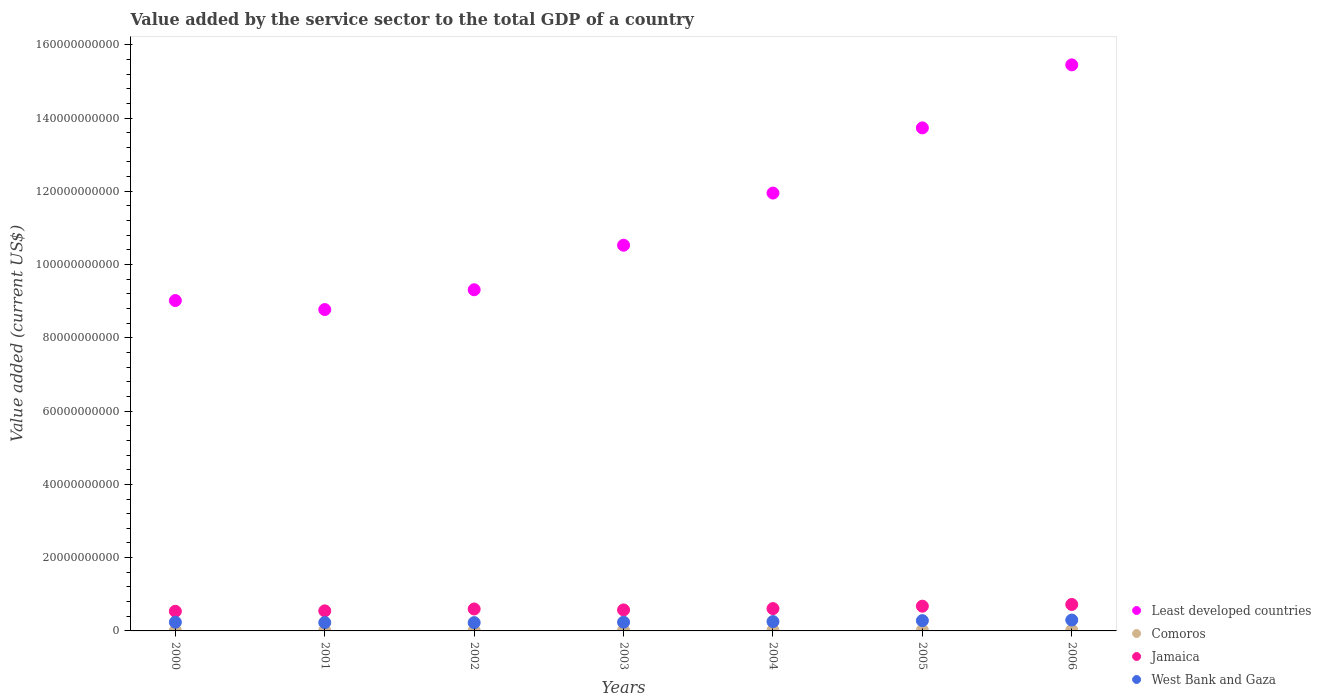Is the number of dotlines equal to the number of legend labels?
Keep it short and to the point. Yes. What is the value added by the service sector to the total GDP in Least developed countries in 2003?
Your answer should be very brief. 1.05e+11. Across all years, what is the maximum value added by the service sector to the total GDP in Jamaica?
Your response must be concise. 7.22e+09. Across all years, what is the minimum value added by the service sector to the total GDP in Jamaica?
Keep it short and to the point. 5.36e+09. In which year was the value added by the service sector to the total GDP in Comoros maximum?
Offer a very short reply. 2006. What is the total value added by the service sector to the total GDP in Comoros in the graph?
Your answer should be very brief. 1.02e+09. What is the difference between the value added by the service sector to the total GDP in Jamaica in 2000 and that in 2003?
Your answer should be very brief. -3.69e+08. What is the difference between the value added by the service sector to the total GDP in Comoros in 2003 and the value added by the service sector to the total GDP in Jamaica in 2005?
Offer a terse response. -6.60e+09. What is the average value added by the service sector to the total GDP in West Bank and Gaza per year?
Provide a short and direct response. 2.52e+09. In the year 2000, what is the difference between the value added by the service sector to the total GDP in West Bank and Gaza and value added by the service sector to the total GDP in Jamaica?
Give a very brief answer. -2.99e+09. What is the ratio of the value added by the service sector to the total GDP in Jamaica in 2001 to that in 2002?
Your answer should be compact. 0.91. Is the value added by the service sector to the total GDP in West Bank and Gaza in 2002 less than that in 2003?
Give a very brief answer. Yes. Is the difference between the value added by the service sector to the total GDP in West Bank and Gaza in 2001 and 2004 greater than the difference between the value added by the service sector to the total GDP in Jamaica in 2001 and 2004?
Keep it short and to the point. Yes. What is the difference between the highest and the second highest value added by the service sector to the total GDP in West Bank and Gaza?
Provide a short and direct response. 1.62e+08. What is the difference between the highest and the lowest value added by the service sector to the total GDP in West Bank and Gaza?
Offer a terse response. 7.10e+08. In how many years, is the value added by the service sector to the total GDP in Jamaica greater than the average value added by the service sector to the total GDP in Jamaica taken over all years?
Give a very brief answer. 3. Is the sum of the value added by the service sector to the total GDP in Jamaica in 2000 and 2003 greater than the maximum value added by the service sector to the total GDP in West Bank and Gaza across all years?
Provide a short and direct response. Yes. Is it the case that in every year, the sum of the value added by the service sector to the total GDP in Jamaica and value added by the service sector to the total GDP in West Bank and Gaza  is greater than the sum of value added by the service sector to the total GDP in Least developed countries and value added by the service sector to the total GDP in Comoros?
Give a very brief answer. No. Does the value added by the service sector to the total GDP in Jamaica monotonically increase over the years?
Give a very brief answer. No. Is the value added by the service sector to the total GDP in Comoros strictly greater than the value added by the service sector to the total GDP in West Bank and Gaza over the years?
Make the answer very short. No. How many years are there in the graph?
Provide a short and direct response. 7. Does the graph contain grids?
Keep it short and to the point. No. How many legend labels are there?
Ensure brevity in your answer.  4. What is the title of the graph?
Provide a short and direct response. Value added by the service sector to the total GDP of a country. What is the label or title of the X-axis?
Give a very brief answer. Years. What is the label or title of the Y-axis?
Give a very brief answer. Value added (current US$). What is the Value added (current US$) in Least developed countries in 2000?
Ensure brevity in your answer.  9.02e+1. What is the Value added (current US$) in Comoros in 2000?
Offer a very short reply. 1.02e+08. What is the Value added (current US$) in Jamaica in 2000?
Give a very brief answer. 5.36e+09. What is the Value added (current US$) of West Bank and Gaza in 2000?
Offer a very short reply. 2.37e+09. What is the Value added (current US$) in Least developed countries in 2001?
Give a very brief answer. 8.77e+1. What is the Value added (current US$) of Comoros in 2001?
Your answer should be compact. 1.04e+08. What is the Value added (current US$) of Jamaica in 2001?
Give a very brief answer. 5.47e+09. What is the Value added (current US$) in West Bank and Gaza in 2001?
Make the answer very short. 2.28e+09. What is the Value added (current US$) in Least developed countries in 2002?
Offer a very short reply. 9.31e+1. What is the Value added (current US$) in Comoros in 2002?
Offer a terse response. 1.16e+08. What is the Value added (current US$) in Jamaica in 2002?
Your answer should be very brief. 5.99e+09. What is the Value added (current US$) of West Bank and Gaza in 2002?
Offer a very short reply. 2.26e+09. What is the Value added (current US$) of Least developed countries in 2003?
Your answer should be very brief. 1.05e+11. What is the Value added (current US$) in Comoros in 2003?
Provide a succinct answer. 1.50e+08. What is the Value added (current US$) in Jamaica in 2003?
Make the answer very short. 5.73e+09. What is the Value added (current US$) of West Bank and Gaza in 2003?
Your answer should be very brief. 2.38e+09. What is the Value added (current US$) in Least developed countries in 2004?
Make the answer very short. 1.20e+11. What is the Value added (current US$) in Comoros in 2004?
Make the answer very short. 1.73e+08. What is the Value added (current US$) of Jamaica in 2004?
Make the answer very short. 6.09e+09. What is the Value added (current US$) in West Bank and Gaza in 2004?
Provide a succinct answer. 2.55e+09. What is the Value added (current US$) of Least developed countries in 2005?
Your answer should be very brief. 1.37e+11. What is the Value added (current US$) of Comoros in 2005?
Your response must be concise. 1.79e+08. What is the Value added (current US$) in Jamaica in 2005?
Your answer should be compact. 6.75e+09. What is the Value added (current US$) in West Bank and Gaza in 2005?
Give a very brief answer. 2.81e+09. What is the Value added (current US$) of Least developed countries in 2006?
Keep it short and to the point. 1.55e+11. What is the Value added (current US$) of Comoros in 2006?
Give a very brief answer. 1.92e+08. What is the Value added (current US$) in Jamaica in 2006?
Your response must be concise. 7.22e+09. What is the Value added (current US$) in West Bank and Gaza in 2006?
Make the answer very short. 2.97e+09. Across all years, what is the maximum Value added (current US$) of Least developed countries?
Give a very brief answer. 1.55e+11. Across all years, what is the maximum Value added (current US$) in Comoros?
Keep it short and to the point. 1.92e+08. Across all years, what is the maximum Value added (current US$) in Jamaica?
Offer a very short reply. 7.22e+09. Across all years, what is the maximum Value added (current US$) of West Bank and Gaza?
Your answer should be very brief. 2.97e+09. Across all years, what is the minimum Value added (current US$) in Least developed countries?
Keep it short and to the point. 8.77e+1. Across all years, what is the minimum Value added (current US$) in Comoros?
Make the answer very short. 1.02e+08. Across all years, what is the minimum Value added (current US$) of Jamaica?
Provide a short and direct response. 5.36e+09. Across all years, what is the minimum Value added (current US$) in West Bank and Gaza?
Make the answer very short. 2.26e+09. What is the total Value added (current US$) of Least developed countries in the graph?
Offer a very short reply. 7.88e+11. What is the total Value added (current US$) of Comoros in the graph?
Your response must be concise. 1.02e+09. What is the total Value added (current US$) in Jamaica in the graph?
Keep it short and to the point. 4.26e+1. What is the total Value added (current US$) in West Bank and Gaza in the graph?
Provide a short and direct response. 1.76e+1. What is the difference between the Value added (current US$) in Least developed countries in 2000 and that in 2001?
Offer a very short reply. 2.46e+09. What is the difference between the Value added (current US$) of Comoros in 2000 and that in 2001?
Give a very brief answer. -2.16e+06. What is the difference between the Value added (current US$) in Jamaica in 2000 and that in 2001?
Your response must be concise. -1.09e+08. What is the difference between the Value added (current US$) of West Bank and Gaza in 2000 and that in 2001?
Your answer should be compact. 9.27e+07. What is the difference between the Value added (current US$) in Least developed countries in 2000 and that in 2002?
Ensure brevity in your answer.  -2.95e+09. What is the difference between the Value added (current US$) of Comoros in 2000 and that in 2002?
Provide a succinct answer. -1.46e+07. What is the difference between the Value added (current US$) of Jamaica in 2000 and that in 2002?
Your answer should be very brief. -6.23e+08. What is the difference between the Value added (current US$) in West Bank and Gaza in 2000 and that in 2002?
Your answer should be very brief. 1.14e+08. What is the difference between the Value added (current US$) in Least developed countries in 2000 and that in 2003?
Ensure brevity in your answer.  -1.51e+1. What is the difference between the Value added (current US$) of Comoros in 2000 and that in 2003?
Provide a short and direct response. -4.79e+07. What is the difference between the Value added (current US$) of Jamaica in 2000 and that in 2003?
Make the answer very short. -3.69e+08. What is the difference between the Value added (current US$) of West Bank and Gaza in 2000 and that in 2003?
Provide a short and direct response. -2.80e+06. What is the difference between the Value added (current US$) of Least developed countries in 2000 and that in 2004?
Provide a succinct answer. -2.93e+1. What is the difference between the Value added (current US$) in Comoros in 2000 and that in 2004?
Keep it short and to the point. -7.17e+07. What is the difference between the Value added (current US$) of Jamaica in 2000 and that in 2004?
Give a very brief answer. -7.27e+08. What is the difference between the Value added (current US$) of West Bank and Gaza in 2000 and that in 2004?
Make the answer very short. -1.76e+08. What is the difference between the Value added (current US$) of Least developed countries in 2000 and that in 2005?
Provide a succinct answer. -4.71e+1. What is the difference between the Value added (current US$) of Comoros in 2000 and that in 2005?
Your response must be concise. -7.70e+07. What is the difference between the Value added (current US$) in Jamaica in 2000 and that in 2005?
Your response must be concise. -1.39e+09. What is the difference between the Value added (current US$) of West Bank and Gaza in 2000 and that in 2005?
Ensure brevity in your answer.  -4.35e+08. What is the difference between the Value added (current US$) in Least developed countries in 2000 and that in 2006?
Keep it short and to the point. -6.43e+1. What is the difference between the Value added (current US$) in Comoros in 2000 and that in 2006?
Provide a short and direct response. -9.08e+07. What is the difference between the Value added (current US$) in Jamaica in 2000 and that in 2006?
Ensure brevity in your answer.  -1.86e+09. What is the difference between the Value added (current US$) in West Bank and Gaza in 2000 and that in 2006?
Give a very brief answer. -5.97e+08. What is the difference between the Value added (current US$) in Least developed countries in 2001 and that in 2002?
Your answer should be compact. -5.40e+09. What is the difference between the Value added (current US$) in Comoros in 2001 and that in 2002?
Your answer should be very brief. -1.24e+07. What is the difference between the Value added (current US$) of Jamaica in 2001 and that in 2002?
Offer a very short reply. -5.14e+08. What is the difference between the Value added (current US$) in West Bank and Gaza in 2001 and that in 2002?
Offer a very short reply. 2.08e+07. What is the difference between the Value added (current US$) of Least developed countries in 2001 and that in 2003?
Provide a short and direct response. -1.76e+1. What is the difference between the Value added (current US$) in Comoros in 2001 and that in 2003?
Your answer should be compact. -4.57e+07. What is the difference between the Value added (current US$) of Jamaica in 2001 and that in 2003?
Your answer should be compact. -2.60e+08. What is the difference between the Value added (current US$) of West Bank and Gaza in 2001 and that in 2003?
Ensure brevity in your answer.  -9.55e+07. What is the difference between the Value added (current US$) of Least developed countries in 2001 and that in 2004?
Provide a short and direct response. -3.18e+1. What is the difference between the Value added (current US$) in Comoros in 2001 and that in 2004?
Keep it short and to the point. -6.96e+07. What is the difference between the Value added (current US$) of Jamaica in 2001 and that in 2004?
Keep it short and to the point. -6.18e+08. What is the difference between the Value added (current US$) in West Bank and Gaza in 2001 and that in 2004?
Ensure brevity in your answer.  -2.69e+08. What is the difference between the Value added (current US$) in Least developed countries in 2001 and that in 2005?
Provide a succinct answer. -4.96e+1. What is the difference between the Value added (current US$) of Comoros in 2001 and that in 2005?
Your answer should be compact. -7.48e+07. What is the difference between the Value added (current US$) in Jamaica in 2001 and that in 2005?
Make the answer very short. -1.28e+09. What is the difference between the Value added (current US$) in West Bank and Gaza in 2001 and that in 2005?
Give a very brief answer. -5.28e+08. What is the difference between the Value added (current US$) of Least developed countries in 2001 and that in 2006?
Your answer should be very brief. -6.68e+1. What is the difference between the Value added (current US$) of Comoros in 2001 and that in 2006?
Your response must be concise. -8.86e+07. What is the difference between the Value added (current US$) in Jamaica in 2001 and that in 2006?
Make the answer very short. -1.75e+09. What is the difference between the Value added (current US$) in West Bank and Gaza in 2001 and that in 2006?
Make the answer very short. -6.89e+08. What is the difference between the Value added (current US$) in Least developed countries in 2002 and that in 2003?
Give a very brief answer. -1.22e+1. What is the difference between the Value added (current US$) in Comoros in 2002 and that in 2003?
Provide a succinct answer. -3.34e+07. What is the difference between the Value added (current US$) of Jamaica in 2002 and that in 2003?
Provide a short and direct response. 2.54e+08. What is the difference between the Value added (current US$) in West Bank and Gaza in 2002 and that in 2003?
Make the answer very short. -1.16e+08. What is the difference between the Value added (current US$) in Least developed countries in 2002 and that in 2004?
Your response must be concise. -2.64e+1. What is the difference between the Value added (current US$) of Comoros in 2002 and that in 2004?
Offer a very short reply. -5.72e+07. What is the difference between the Value added (current US$) in Jamaica in 2002 and that in 2004?
Offer a terse response. -1.04e+08. What is the difference between the Value added (current US$) of West Bank and Gaza in 2002 and that in 2004?
Offer a terse response. -2.89e+08. What is the difference between the Value added (current US$) of Least developed countries in 2002 and that in 2005?
Your answer should be compact. -4.42e+1. What is the difference between the Value added (current US$) of Comoros in 2002 and that in 2005?
Offer a terse response. -6.24e+07. What is the difference between the Value added (current US$) of Jamaica in 2002 and that in 2005?
Make the answer very short. -7.65e+08. What is the difference between the Value added (current US$) of West Bank and Gaza in 2002 and that in 2005?
Your response must be concise. -5.49e+08. What is the difference between the Value added (current US$) of Least developed countries in 2002 and that in 2006?
Your answer should be compact. -6.14e+1. What is the difference between the Value added (current US$) in Comoros in 2002 and that in 2006?
Ensure brevity in your answer.  -7.62e+07. What is the difference between the Value added (current US$) of Jamaica in 2002 and that in 2006?
Keep it short and to the point. -1.23e+09. What is the difference between the Value added (current US$) of West Bank and Gaza in 2002 and that in 2006?
Provide a succinct answer. -7.10e+08. What is the difference between the Value added (current US$) of Least developed countries in 2003 and that in 2004?
Offer a very short reply. -1.42e+1. What is the difference between the Value added (current US$) in Comoros in 2003 and that in 2004?
Give a very brief answer. -2.38e+07. What is the difference between the Value added (current US$) in Jamaica in 2003 and that in 2004?
Offer a terse response. -3.58e+08. What is the difference between the Value added (current US$) in West Bank and Gaza in 2003 and that in 2004?
Keep it short and to the point. -1.73e+08. What is the difference between the Value added (current US$) of Least developed countries in 2003 and that in 2005?
Your answer should be compact. -3.20e+1. What is the difference between the Value added (current US$) of Comoros in 2003 and that in 2005?
Your answer should be very brief. -2.91e+07. What is the difference between the Value added (current US$) of Jamaica in 2003 and that in 2005?
Ensure brevity in your answer.  -1.02e+09. What is the difference between the Value added (current US$) of West Bank and Gaza in 2003 and that in 2005?
Make the answer very short. -4.32e+08. What is the difference between the Value added (current US$) of Least developed countries in 2003 and that in 2006?
Your answer should be compact. -4.92e+1. What is the difference between the Value added (current US$) of Comoros in 2003 and that in 2006?
Provide a short and direct response. -4.28e+07. What is the difference between the Value added (current US$) in Jamaica in 2003 and that in 2006?
Your answer should be very brief. -1.49e+09. What is the difference between the Value added (current US$) in West Bank and Gaza in 2003 and that in 2006?
Your response must be concise. -5.94e+08. What is the difference between the Value added (current US$) of Least developed countries in 2004 and that in 2005?
Your answer should be compact. -1.78e+1. What is the difference between the Value added (current US$) of Comoros in 2004 and that in 2005?
Offer a very short reply. -5.24e+06. What is the difference between the Value added (current US$) of Jamaica in 2004 and that in 2005?
Your answer should be very brief. -6.61e+08. What is the difference between the Value added (current US$) of West Bank and Gaza in 2004 and that in 2005?
Give a very brief answer. -2.59e+08. What is the difference between the Value added (current US$) of Least developed countries in 2004 and that in 2006?
Keep it short and to the point. -3.50e+1. What is the difference between the Value added (current US$) in Comoros in 2004 and that in 2006?
Provide a short and direct response. -1.90e+07. What is the difference between the Value added (current US$) in Jamaica in 2004 and that in 2006?
Your answer should be very brief. -1.13e+09. What is the difference between the Value added (current US$) in West Bank and Gaza in 2004 and that in 2006?
Provide a succinct answer. -4.21e+08. What is the difference between the Value added (current US$) of Least developed countries in 2005 and that in 2006?
Your answer should be very brief. -1.72e+1. What is the difference between the Value added (current US$) in Comoros in 2005 and that in 2006?
Make the answer very short. -1.38e+07. What is the difference between the Value added (current US$) in Jamaica in 2005 and that in 2006?
Offer a terse response. -4.69e+08. What is the difference between the Value added (current US$) of West Bank and Gaza in 2005 and that in 2006?
Give a very brief answer. -1.62e+08. What is the difference between the Value added (current US$) in Least developed countries in 2000 and the Value added (current US$) in Comoros in 2001?
Offer a terse response. 9.01e+1. What is the difference between the Value added (current US$) in Least developed countries in 2000 and the Value added (current US$) in Jamaica in 2001?
Your answer should be compact. 8.47e+1. What is the difference between the Value added (current US$) in Least developed countries in 2000 and the Value added (current US$) in West Bank and Gaza in 2001?
Your response must be concise. 8.79e+1. What is the difference between the Value added (current US$) in Comoros in 2000 and the Value added (current US$) in Jamaica in 2001?
Your answer should be compact. -5.37e+09. What is the difference between the Value added (current US$) in Comoros in 2000 and the Value added (current US$) in West Bank and Gaza in 2001?
Make the answer very short. -2.18e+09. What is the difference between the Value added (current US$) of Jamaica in 2000 and the Value added (current US$) of West Bank and Gaza in 2001?
Make the answer very short. 3.08e+09. What is the difference between the Value added (current US$) in Least developed countries in 2000 and the Value added (current US$) in Comoros in 2002?
Your answer should be compact. 9.01e+1. What is the difference between the Value added (current US$) in Least developed countries in 2000 and the Value added (current US$) in Jamaica in 2002?
Offer a terse response. 8.42e+1. What is the difference between the Value added (current US$) in Least developed countries in 2000 and the Value added (current US$) in West Bank and Gaza in 2002?
Your response must be concise. 8.79e+1. What is the difference between the Value added (current US$) of Comoros in 2000 and the Value added (current US$) of Jamaica in 2002?
Offer a very short reply. -5.89e+09. What is the difference between the Value added (current US$) of Comoros in 2000 and the Value added (current US$) of West Bank and Gaza in 2002?
Provide a short and direct response. -2.16e+09. What is the difference between the Value added (current US$) in Jamaica in 2000 and the Value added (current US$) in West Bank and Gaza in 2002?
Give a very brief answer. 3.11e+09. What is the difference between the Value added (current US$) of Least developed countries in 2000 and the Value added (current US$) of Comoros in 2003?
Offer a terse response. 9.00e+1. What is the difference between the Value added (current US$) in Least developed countries in 2000 and the Value added (current US$) in Jamaica in 2003?
Your answer should be very brief. 8.44e+1. What is the difference between the Value added (current US$) in Least developed countries in 2000 and the Value added (current US$) in West Bank and Gaza in 2003?
Give a very brief answer. 8.78e+1. What is the difference between the Value added (current US$) in Comoros in 2000 and the Value added (current US$) in Jamaica in 2003?
Make the answer very short. -5.63e+09. What is the difference between the Value added (current US$) in Comoros in 2000 and the Value added (current US$) in West Bank and Gaza in 2003?
Your answer should be compact. -2.27e+09. What is the difference between the Value added (current US$) in Jamaica in 2000 and the Value added (current US$) in West Bank and Gaza in 2003?
Your answer should be very brief. 2.99e+09. What is the difference between the Value added (current US$) of Least developed countries in 2000 and the Value added (current US$) of Comoros in 2004?
Offer a very short reply. 9.00e+1. What is the difference between the Value added (current US$) of Least developed countries in 2000 and the Value added (current US$) of Jamaica in 2004?
Your response must be concise. 8.41e+1. What is the difference between the Value added (current US$) in Least developed countries in 2000 and the Value added (current US$) in West Bank and Gaza in 2004?
Your response must be concise. 8.76e+1. What is the difference between the Value added (current US$) in Comoros in 2000 and the Value added (current US$) in Jamaica in 2004?
Give a very brief answer. -5.99e+09. What is the difference between the Value added (current US$) of Comoros in 2000 and the Value added (current US$) of West Bank and Gaza in 2004?
Your answer should be very brief. -2.45e+09. What is the difference between the Value added (current US$) in Jamaica in 2000 and the Value added (current US$) in West Bank and Gaza in 2004?
Provide a succinct answer. 2.82e+09. What is the difference between the Value added (current US$) in Least developed countries in 2000 and the Value added (current US$) in Comoros in 2005?
Offer a terse response. 9.00e+1. What is the difference between the Value added (current US$) of Least developed countries in 2000 and the Value added (current US$) of Jamaica in 2005?
Make the answer very short. 8.34e+1. What is the difference between the Value added (current US$) of Least developed countries in 2000 and the Value added (current US$) of West Bank and Gaza in 2005?
Ensure brevity in your answer.  8.74e+1. What is the difference between the Value added (current US$) of Comoros in 2000 and the Value added (current US$) of Jamaica in 2005?
Make the answer very short. -6.65e+09. What is the difference between the Value added (current US$) of Comoros in 2000 and the Value added (current US$) of West Bank and Gaza in 2005?
Provide a short and direct response. -2.71e+09. What is the difference between the Value added (current US$) of Jamaica in 2000 and the Value added (current US$) of West Bank and Gaza in 2005?
Your answer should be compact. 2.56e+09. What is the difference between the Value added (current US$) of Least developed countries in 2000 and the Value added (current US$) of Comoros in 2006?
Keep it short and to the point. 9.00e+1. What is the difference between the Value added (current US$) of Least developed countries in 2000 and the Value added (current US$) of Jamaica in 2006?
Offer a terse response. 8.30e+1. What is the difference between the Value added (current US$) of Least developed countries in 2000 and the Value added (current US$) of West Bank and Gaza in 2006?
Provide a succinct answer. 8.72e+1. What is the difference between the Value added (current US$) of Comoros in 2000 and the Value added (current US$) of Jamaica in 2006?
Provide a succinct answer. -7.12e+09. What is the difference between the Value added (current US$) of Comoros in 2000 and the Value added (current US$) of West Bank and Gaza in 2006?
Keep it short and to the point. -2.87e+09. What is the difference between the Value added (current US$) in Jamaica in 2000 and the Value added (current US$) in West Bank and Gaza in 2006?
Keep it short and to the point. 2.40e+09. What is the difference between the Value added (current US$) in Least developed countries in 2001 and the Value added (current US$) in Comoros in 2002?
Give a very brief answer. 8.76e+1. What is the difference between the Value added (current US$) of Least developed countries in 2001 and the Value added (current US$) of Jamaica in 2002?
Your answer should be compact. 8.17e+1. What is the difference between the Value added (current US$) in Least developed countries in 2001 and the Value added (current US$) in West Bank and Gaza in 2002?
Give a very brief answer. 8.55e+1. What is the difference between the Value added (current US$) of Comoros in 2001 and the Value added (current US$) of Jamaica in 2002?
Provide a succinct answer. -5.88e+09. What is the difference between the Value added (current US$) of Comoros in 2001 and the Value added (current US$) of West Bank and Gaza in 2002?
Keep it short and to the point. -2.15e+09. What is the difference between the Value added (current US$) of Jamaica in 2001 and the Value added (current US$) of West Bank and Gaza in 2002?
Make the answer very short. 3.21e+09. What is the difference between the Value added (current US$) in Least developed countries in 2001 and the Value added (current US$) in Comoros in 2003?
Offer a terse response. 8.76e+1. What is the difference between the Value added (current US$) of Least developed countries in 2001 and the Value added (current US$) of Jamaica in 2003?
Provide a short and direct response. 8.20e+1. What is the difference between the Value added (current US$) in Least developed countries in 2001 and the Value added (current US$) in West Bank and Gaza in 2003?
Your response must be concise. 8.53e+1. What is the difference between the Value added (current US$) in Comoros in 2001 and the Value added (current US$) in Jamaica in 2003?
Your answer should be very brief. -5.63e+09. What is the difference between the Value added (current US$) in Comoros in 2001 and the Value added (current US$) in West Bank and Gaza in 2003?
Provide a succinct answer. -2.27e+09. What is the difference between the Value added (current US$) in Jamaica in 2001 and the Value added (current US$) in West Bank and Gaza in 2003?
Provide a short and direct response. 3.10e+09. What is the difference between the Value added (current US$) of Least developed countries in 2001 and the Value added (current US$) of Comoros in 2004?
Your answer should be very brief. 8.76e+1. What is the difference between the Value added (current US$) of Least developed countries in 2001 and the Value added (current US$) of Jamaica in 2004?
Keep it short and to the point. 8.16e+1. What is the difference between the Value added (current US$) in Least developed countries in 2001 and the Value added (current US$) in West Bank and Gaza in 2004?
Provide a succinct answer. 8.52e+1. What is the difference between the Value added (current US$) of Comoros in 2001 and the Value added (current US$) of Jamaica in 2004?
Provide a short and direct response. -5.99e+09. What is the difference between the Value added (current US$) of Comoros in 2001 and the Value added (current US$) of West Bank and Gaza in 2004?
Make the answer very short. -2.44e+09. What is the difference between the Value added (current US$) of Jamaica in 2001 and the Value added (current US$) of West Bank and Gaza in 2004?
Offer a very short reply. 2.93e+09. What is the difference between the Value added (current US$) of Least developed countries in 2001 and the Value added (current US$) of Comoros in 2005?
Your answer should be very brief. 8.75e+1. What is the difference between the Value added (current US$) in Least developed countries in 2001 and the Value added (current US$) in Jamaica in 2005?
Give a very brief answer. 8.10e+1. What is the difference between the Value added (current US$) in Least developed countries in 2001 and the Value added (current US$) in West Bank and Gaza in 2005?
Offer a very short reply. 8.49e+1. What is the difference between the Value added (current US$) of Comoros in 2001 and the Value added (current US$) of Jamaica in 2005?
Provide a succinct answer. -6.65e+09. What is the difference between the Value added (current US$) in Comoros in 2001 and the Value added (current US$) in West Bank and Gaza in 2005?
Make the answer very short. -2.70e+09. What is the difference between the Value added (current US$) of Jamaica in 2001 and the Value added (current US$) of West Bank and Gaza in 2005?
Ensure brevity in your answer.  2.67e+09. What is the difference between the Value added (current US$) in Least developed countries in 2001 and the Value added (current US$) in Comoros in 2006?
Keep it short and to the point. 8.75e+1. What is the difference between the Value added (current US$) in Least developed countries in 2001 and the Value added (current US$) in Jamaica in 2006?
Your response must be concise. 8.05e+1. What is the difference between the Value added (current US$) of Least developed countries in 2001 and the Value added (current US$) of West Bank and Gaza in 2006?
Give a very brief answer. 8.48e+1. What is the difference between the Value added (current US$) in Comoros in 2001 and the Value added (current US$) in Jamaica in 2006?
Your response must be concise. -7.12e+09. What is the difference between the Value added (current US$) of Comoros in 2001 and the Value added (current US$) of West Bank and Gaza in 2006?
Provide a succinct answer. -2.87e+09. What is the difference between the Value added (current US$) in Jamaica in 2001 and the Value added (current US$) in West Bank and Gaza in 2006?
Make the answer very short. 2.50e+09. What is the difference between the Value added (current US$) of Least developed countries in 2002 and the Value added (current US$) of Comoros in 2003?
Give a very brief answer. 9.30e+1. What is the difference between the Value added (current US$) in Least developed countries in 2002 and the Value added (current US$) in Jamaica in 2003?
Give a very brief answer. 8.74e+1. What is the difference between the Value added (current US$) of Least developed countries in 2002 and the Value added (current US$) of West Bank and Gaza in 2003?
Offer a very short reply. 9.08e+1. What is the difference between the Value added (current US$) of Comoros in 2002 and the Value added (current US$) of Jamaica in 2003?
Your answer should be very brief. -5.62e+09. What is the difference between the Value added (current US$) of Comoros in 2002 and the Value added (current US$) of West Bank and Gaza in 2003?
Your answer should be very brief. -2.26e+09. What is the difference between the Value added (current US$) of Jamaica in 2002 and the Value added (current US$) of West Bank and Gaza in 2003?
Offer a very short reply. 3.61e+09. What is the difference between the Value added (current US$) in Least developed countries in 2002 and the Value added (current US$) in Comoros in 2004?
Offer a terse response. 9.30e+1. What is the difference between the Value added (current US$) in Least developed countries in 2002 and the Value added (current US$) in Jamaica in 2004?
Your answer should be compact. 8.70e+1. What is the difference between the Value added (current US$) in Least developed countries in 2002 and the Value added (current US$) in West Bank and Gaza in 2004?
Make the answer very short. 9.06e+1. What is the difference between the Value added (current US$) of Comoros in 2002 and the Value added (current US$) of Jamaica in 2004?
Give a very brief answer. -5.98e+09. What is the difference between the Value added (current US$) of Comoros in 2002 and the Value added (current US$) of West Bank and Gaza in 2004?
Your answer should be very brief. -2.43e+09. What is the difference between the Value added (current US$) of Jamaica in 2002 and the Value added (current US$) of West Bank and Gaza in 2004?
Make the answer very short. 3.44e+09. What is the difference between the Value added (current US$) of Least developed countries in 2002 and the Value added (current US$) of Comoros in 2005?
Ensure brevity in your answer.  9.29e+1. What is the difference between the Value added (current US$) in Least developed countries in 2002 and the Value added (current US$) in Jamaica in 2005?
Your answer should be compact. 8.64e+1. What is the difference between the Value added (current US$) of Least developed countries in 2002 and the Value added (current US$) of West Bank and Gaza in 2005?
Keep it short and to the point. 9.03e+1. What is the difference between the Value added (current US$) of Comoros in 2002 and the Value added (current US$) of Jamaica in 2005?
Offer a very short reply. -6.64e+09. What is the difference between the Value added (current US$) of Comoros in 2002 and the Value added (current US$) of West Bank and Gaza in 2005?
Keep it short and to the point. -2.69e+09. What is the difference between the Value added (current US$) in Jamaica in 2002 and the Value added (current US$) in West Bank and Gaza in 2005?
Provide a short and direct response. 3.18e+09. What is the difference between the Value added (current US$) in Least developed countries in 2002 and the Value added (current US$) in Comoros in 2006?
Offer a terse response. 9.29e+1. What is the difference between the Value added (current US$) in Least developed countries in 2002 and the Value added (current US$) in Jamaica in 2006?
Your response must be concise. 8.59e+1. What is the difference between the Value added (current US$) in Least developed countries in 2002 and the Value added (current US$) in West Bank and Gaza in 2006?
Your answer should be compact. 9.02e+1. What is the difference between the Value added (current US$) in Comoros in 2002 and the Value added (current US$) in Jamaica in 2006?
Make the answer very short. -7.11e+09. What is the difference between the Value added (current US$) of Comoros in 2002 and the Value added (current US$) of West Bank and Gaza in 2006?
Ensure brevity in your answer.  -2.85e+09. What is the difference between the Value added (current US$) in Jamaica in 2002 and the Value added (current US$) in West Bank and Gaza in 2006?
Your answer should be compact. 3.02e+09. What is the difference between the Value added (current US$) in Least developed countries in 2003 and the Value added (current US$) in Comoros in 2004?
Your answer should be compact. 1.05e+11. What is the difference between the Value added (current US$) in Least developed countries in 2003 and the Value added (current US$) in Jamaica in 2004?
Provide a succinct answer. 9.92e+1. What is the difference between the Value added (current US$) in Least developed countries in 2003 and the Value added (current US$) in West Bank and Gaza in 2004?
Your answer should be very brief. 1.03e+11. What is the difference between the Value added (current US$) in Comoros in 2003 and the Value added (current US$) in Jamaica in 2004?
Ensure brevity in your answer.  -5.94e+09. What is the difference between the Value added (current US$) in Comoros in 2003 and the Value added (current US$) in West Bank and Gaza in 2004?
Your answer should be compact. -2.40e+09. What is the difference between the Value added (current US$) in Jamaica in 2003 and the Value added (current US$) in West Bank and Gaza in 2004?
Give a very brief answer. 3.18e+09. What is the difference between the Value added (current US$) in Least developed countries in 2003 and the Value added (current US$) in Comoros in 2005?
Your response must be concise. 1.05e+11. What is the difference between the Value added (current US$) in Least developed countries in 2003 and the Value added (current US$) in Jamaica in 2005?
Offer a terse response. 9.85e+1. What is the difference between the Value added (current US$) of Least developed countries in 2003 and the Value added (current US$) of West Bank and Gaza in 2005?
Offer a terse response. 1.02e+11. What is the difference between the Value added (current US$) of Comoros in 2003 and the Value added (current US$) of Jamaica in 2005?
Offer a terse response. -6.60e+09. What is the difference between the Value added (current US$) in Comoros in 2003 and the Value added (current US$) in West Bank and Gaza in 2005?
Your answer should be very brief. -2.66e+09. What is the difference between the Value added (current US$) of Jamaica in 2003 and the Value added (current US$) of West Bank and Gaza in 2005?
Your response must be concise. 2.93e+09. What is the difference between the Value added (current US$) in Least developed countries in 2003 and the Value added (current US$) in Comoros in 2006?
Your response must be concise. 1.05e+11. What is the difference between the Value added (current US$) in Least developed countries in 2003 and the Value added (current US$) in Jamaica in 2006?
Keep it short and to the point. 9.81e+1. What is the difference between the Value added (current US$) in Least developed countries in 2003 and the Value added (current US$) in West Bank and Gaza in 2006?
Your answer should be very brief. 1.02e+11. What is the difference between the Value added (current US$) of Comoros in 2003 and the Value added (current US$) of Jamaica in 2006?
Your answer should be very brief. -7.07e+09. What is the difference between the Value added (current US$) in Comoros in 2003 and the Value added (current US$) in West Bank and Gaza in 2006?
Ensure brevity in your answer.  -2.82e+09. What is the difference between the Value added (current US$) of Jamaica in 2003 and the Value added (current US$) of West Bank and Gaza in 2006?
Your response must be concise. 2.76e+09. What is the difference between the Value added (current US$) of Least developed countries in 2004 and the Value added (current US$) of Comoros in 2005?
Provide a succinct answer. 1.19e+11. What is the difference between the Value added (current US$) of Least developed countries in 2004 and the Value added (current US$) of Jamaica in 2005?
Provide a short and direct response. 1.13e+11. What is the difference between the Value added (current US$) of Least developed countries in 2004 and the Value added (current US$) of West Bank and Gaza in 2005?
Offer a very short reply. 1.17e+11. What is the difference between the Value added (current US$) in Comoros in 2004 and the Value added (current US$) in Jamaica in 2005?
Keep it short and to the point. -6.58e+09. What is the difference between the Value added (current US$) in Comoros in 2004 and the Value added (current US$) in West Bank and Gaza in 2005?
Ensure brevity in your answer.  -2.63e+09. What is the difference between the Value added (current US$) of Jamaica in 2004 and the Value added (current US$) of West Bank and Gaza in 2005?
Give a very brief answer. 3.28e+09. What is the difference between the Value added (current US$) in Least developed countries in 2004 and the Value added (current US$) in Comoros in 2006?
Ensure brevity in your answer.  1.19e+11. What is the difference between the Value added (current US$) in Least developed countries in 2004 and the Value added (current US$) in Jamaica in 2006?
Your response must be concise. 1.12e+11. What is the difference between the Value added (current US$) of Least developed countries in 2004 and the Value added (current US$) of West Bank and Gaza in 2006?
Ensure brevity in your answer.  1.17e+11. What is the difference between the Value added (current US$) in Comoros in 2004 and the Value added (current US$) in Jamaica in 2006?
Offer a terse response. -7.05e+09. What is the difference between the Value added (current US$) in Comoros in 2004 and the Value added (current US$) in West Bank and Gaza in 2006?
Ensure brevity in your answer.  -2.80e+09. What is the difference between the Value added (current US$) in Jamaica in 2004 and the Value added (current US$) in West Bank and Gaza in 2006?
Give a very brief answer. 3.12e+09. What is the difference between the Value added (current US$) in Least developed countries in 2005 and the Value added (current US$) in Comoros in 2006?
Provide a short and direct response. 1.37e+11. What is the difference between the Value added (current US$) in Least developed countries in 2005 and the Value added (current US$) in Jamaica in 2006?
Offer a terse response. 1.30e+11. What is the difference between the Value added (current US$) in Least developed countries in 2005 and the Value added (current US$) in West Bank and Gaza in 2006?
Offer a terse response. 1.34e+11. What is the difference between the Value added (current US$) in Comoros in 2005 and the Value added (current US$) in Jamaica in 2006?
Your answer should be compact. -7.04e+09. What is the difference between the Value added (current US$) of Comoros in 2005 and the Value added (current US$) of West Bank and Gaza in 2006?
Offer a terse response. -2.79e+09. What is the difference between the Value added (current US$) in Jamaica in 2005 and the Value added (current US$) in West Bank and Gaza in 2006?
Provide a short and direct response. 3.78e+09. What is the average Value added (current US$) in Least developed countries per year?
Your response must be concise. 1.13e+11. What is the average Value added (current US$) of Comoros per year?
Make the answer very short. 1.45e+08. What is the average Value added (current US$) of Jamaica per year?
Ensure brevity in your answer.  6.09e+09. What is the average Value added (current US$) in West Bank and Gaza per year?
Your answer should be very brief. 2.52e+09. In the year 2000, what is the difference between the Value added (current US$) in Least developed countries and Value added (current US$) in Comoros?
Your answer should be compact. 9.01e+1. In the year 2000, what is the difference between the Value added (current US$) of Least developed countries and Value added (current US$) of Jamaica?
Your answer should be compact. 8.48e+1. In the year 2000, what is the difference between the Value added (current US$) in Least developed countries and Value added (current US$) in West Bank and Gaza?
Provide a succinct answer. 8.78e+1. In the year 2000, what is the difference between the Value added (current US$) of Comoros and Value added (current US$) of Jamaica?
Ensure brevity in your answer.  -5.26e+09. In the year 2000, what is the difference between the Value added (current US$) in Comoros and Value added (current US$) in West Bank and Gaza?
Provide a succinct answer. -2.27e+09. In the year 2000, what is the difference between the Value added (current US$) in Jamaica and Value added (current US$) in West Bank and Gaza?
Make the answer very short. 2.99e+09. In the year 2001, what is the difference between the Value added (current US$) of Least developed countries and Value added (current US$) of Comoros?
Keep it short and to the point. 8.76e+1. In the year 2001, what is the difference between the Value added (current US$) of Least developed countries and Value added (current US$) of Jamaica?
Provide a succinct answer. 8.23e+1. In the year 2001, what is the difference between the Value added (current US$) in Least developed countries and Value added (current US$) in West Bank and Gaza?
Your answer should be very brief. 8.54e+1. In the year 2001, what is the difference between the Value added (current US$) in Comoros and Value added (current US$) in Jamaica?
Offer a terse response. -5.37e+09. In the year 2001, what is the difference between the Value added (current US$) in Comoros and Value added (current US$) in West Bank and Gaza?
Your answer should be compact. -2.18e+09. In the year 2001, what is the difference between the Value added (current US$) of Jamaica and Value added (current US$) of West Bank and Gaza?
Give a very brief answer. 3.19e+09. In the year 2002, what is the difference between the Value added (current US$) in Least developed countries and Value added (current US$) in Comoros?
Your answer should be very brief. 9.30e+1. In the year 2002, what is the difference between the Value added (current US$) of Least developed countries and Value added (current US$) of Jamaica?
Your answer should be compact. 8.71e+1. In the year 2002, what is the difference between the Value added (current US$) of Least developed countries and Value added (current US$) of West Bank and Gaza?
Ensure brevity in your answer.  9.09e+1. In the year 2002, what is the difference between the Value added (current US$) of Comoros and Value added (current US$) of Jamaica?
Offer a very short reply. -5.87e+09. In the year 2002, what is the difference between the Value added (current US$) of Comoros and Value added (current US$) of West Bank and Gaza?
Your response must be concise. -2.14e+09. In the year 2002, what is the difference between the Value added (current US$) in Jamaica and Value added (current US$) in West Bank and Gaza?
Make the answer very short. 3.73e+09. In the year 2003, what is the difference between the Value added (current US$) of Least developed countries and Value added (current US$) of Comoros?
Provide a short and direct response. 1.05e+11. In the year 2003, what is the difference between the Value added (current US$) in Least developed countries and Value added (current US$) in Jamaica?
Give a very brief answer. 9.95e+1. In the year 2003, what is the difference between the Value added (current US$) in Least developed countries and Value added (current US$) in West Bank and Gaza?
Your answer should be compact. 1.03e+11. In the year 2003, what is the difference between the Value added (current US$) of Comoros and Value added (current US$) of Jamaica?
Offer a terse response. -5.58e+09. In the year 2003, what is the difference between the Value added (current US$) of Comoros and Value added (current US$) of West Bank and Gaza?
Your answer should be compact. -2.23e+09. In the year 2003, what is the difference between the Value added (current US$) of Jamaica and Value added (current US$) of West Bank and Gaza?
Offer a terse response. 3.36e+09. In the year 2004, what is the difference between the Value added (current US$) of Least developed countries and Value added (current US$) of Comoros?
Keep it short and to the point. 1.19e+11. In the year 2004, what is the difference between the Value added (current US$) in Least developed countries and Value added (current US$) in Jamaica?
Give a very brief answer. 1.13e+11. In the year 2004, what is the difference between the Value added (current US$) in Least developed countries and Value added (current US$) in West Bank and Gaza?
Provide a short and direct response. 1.17e+11. In the year 2004, what is the difference between the Value added (current US$) in Comoros and Value added (current US$) in Jamaica?
Your response must be concise. -5.92e+09. In the year 2004, what is the difference between the Value added (current US$) in Comoros and Value added (current US$) in West Bank and Gaza?
Provide a succinct answer. -2.37e+09. In the year 2004, what is the difference between the Value added (current US$) of Jamaica and Value added (current US$) of West Bank and Gaza?
Offer a very short reply. 3.54e+09. In the year 2005, what is the difference between the Value added (current US$) in Least developed countries and Value added (current US$) in Comoros?
Provide a short and direct response. 1.37e+11. In the year 2005, what is the difference between the Value added (current US$) in Least developed countries and Value added (current US$) in Jamaica?
Provide a succinct answer. 1.31e+11. In the year 2005, what is the difference between the Value added (current US$) in Least developed countries and Value added (current US$) in West Bank and Gaza?
Your answer should be very brief. 1.35e+11. In the year 2005, what is the difference between the Value added (current US$) of Comoros and Value added (current US$) of Jamaica?
Provide a succinct answer. -6.57e+09. In the year 2005, what is the difference between the Value added (current US$) of Comoros and Value added (current US$) of West Bank and Gaza?
Make the answer very short. -2.63e+09. In the year 2005, what is the difference between the Value added (current US$) of Jamaica and Value added (current US$) of West Bank and Gaza?
Your response must be concise. 3.94e+09. In the year 2006, what is the difference between the Value added (current US$) in Least developed countries and Value added (current US$) in Comoros?
Offer a very short reply. 1.54e+11. In the year 2006, what is the difference between the Value added (current US$) of Least developed countries and Value added (current US$) of Jamaica?
Your answer should be compact. 1.47e+11. In the year 2006, what is the difference between the Value added (current US$) in Least developed countries and Value added (current US$) in West Bank and Gaza?
Provide a short and direct response. 1.52e+11. In the year 2006, what is the difference between the Value added (current US$) of Comoros and Value added (current US$) of Jamaica?
Your answer should be compact. -7.03e+09. In the year 2006, what is the difference between the Value added (current US$) in Comoros and Value added (current US$) in West Bank and Gaza?
Offer a terse response. -2.78e+09. In the year 2006, what is the difference between the Value added (current US$) of Jamaica and Value added (current US$) of West Bank and Gaza?
Provide a succinct answer. 4.25e+09. What is the ratio of the Value added (current US$) of Least developed countries in 2000 to that in 2001?
Offer a terse response. 1.03. What is the ratio of the Value added (current US$) of Comoros in 2000 to that in 2001?
Provide a short and direct response. 0.98. What is the ratio of the Value added (current US$) of Jamaica in 2000 to that in 2001?
Your answer should be very brief. 0.98. What is the ratio of the Value added (current US$) in West Bank and Gaza in 2000 to that in 2001?
Offer a terse response. 1.04. What is the ratio of the Value added (current US$) of Least developed countries in 2000 to that in 2002?
Your answer should be compact. 0.97. What is the ratio of the Value added (current US$) in Comoros in 2000 to that in 2002?
Give a very brief answer. 0.87. What is the ratio of the Value added (current US$) of Jamaica in 2000 to that in 2002?
Make the answer very short. 0.9. What is the ratio of the Value added (current US$) of West Bank and Gaza in 2000 to that in 2002?
Keep it short and to the point. 1.05. What is the ratio of the Value added (current US$) of Least developed countries in 2000 to that in 2003?
Make the answer very short. 0.86. What is the ratio of the Value added (current US$) in Comoros in 2000 to that in 2003?
Your answer should be very brief. 0.68. What is the ratio of the Value added (current US$) in Jamaica in 2000 to that in 2003?
Your response must be concise. 0.94. What is the ratio of the Value added (current US$) in West Bank and Gaza in 2000 to that in 2003?
Provide a succinct answer. 1. What is the ratio of the Value added (current US$) of Least developed countries in 2000 to that in 2004?
Ensure brevity in your answer.  0.75. What is the ratio of the Value added (current US$) of Comoros in 2000 to that in 2004?
Provide a succinct answer. 0.59. What is the ratio of the Value added (current US$) of Jamaica in 2000 to that in 2004?
Your answer should be very brief. 0.88. What is the ratio of the Value added (current US$) of West Bank and Gaza in 2000 to that in 2004?
Offer a very short reply. 0.93. What is the ratio of the Value added (current US$) in Least developed countries in 2000 to that in 2005?
Your answer should be compact. 0.66. What is the ratio of the Value added (current US$) in Comoros in 2000 to that in 2005?
Ensure brevity in your answer.  0.57. What is the ratio of the Value added (current US$) of Jamaica in 2000 to that in 2005?
Provide a succinct answer. 0.79. What is the ratio of the Value added (current US$) of West Bank and Gaza in 2000 to that in 2005?
Your response must be concise. 0.84. What is the ratio of the Value added (current US$) in Least developed countries in 2000 to that in 2006?
Keep it short and to the point. 0.58. What is the ratio of the Value added (current US$) in Comoros in 2000 to that in 2006?
Your response must be concise. 0.53. What is the ratio of the Value added (current US$) in Jamaica in 2000 to that in 2006?
Make the answer very short. 0.74. What is the ratio of the Value added (current US$) in West Bank and Gaza in 2000 to that in 2006?
Your answer should be compact. 0.8. What is the ratio of the Value added (current US$) in Least developed countries in 2001 to that in 2002?
Provide a succinct answer. 0.94. What is the ratio of the Value added (current US$) of Comoros in 2001 to that in 2002?
Provide a short and direct response. 0.89. What is the ratio of the Value added (current US$) in Jamaica in 2001 to that in 2002?
Provide a succinct answer. 0.91. What is the ratio of the Value added (current US$) of West Bank and Gaza in 2001 to that in 2002?
Your answer should be compact. 1.01. What is the ratio of the Value added (current US$) in Least developed countries in 2001 to that in 2003?
Offer a very short reply. 0.83. What is the ratio of the Value added (current US$) in Comoros in 2001 to that in 2003?
Offer a very short reply. 0.69. What is the ratio of the Value added (current US$) in Jamaica in 2001 to that in 2003?
Your answer should be compact. 0.95. What is the ratio of the Value added (current US$) in West Bank and Gaza in 2001 to that in 2003?
Provide a short and direct response. 0.96. What is the ratio of the Value added (current US$) of Least developed countries in 2001 to that in 2004?
Give a very brief answer. 0.73. What is the ratio of the Value added (current US$) in Comoros in 2001 to that in 2004?
Ensure brevity in your answer.  0.6. What is the ratio of the Value added (current US$) in Jamaica in 2001 to that in 2004?
Ensure brevity in your answer.  0.9. What is the ratio of the Value added (current US$) in West Bank and Gaza in 2001 to that in 2004?
Keep it short and to the point. 0.89. What is the ratio of the Value added (current US$) of Least developed countries in 2001 to that in 2005?
Keep it short and to the point. 0.64. What is the ratio of the Value added (current US$) in Comoros in 2001 to that in 2005?
Your response must be concise. 0.58. What is the ratio of the Value added (current US$) of Jamaica in 2001 to that in 2005?
Offer a very short reply. 0.81. What is the ratio of the Value added (current US$) in West Bank and Gaza in 2001 to that in 2005?
Offer a very short reply. 0.81. What is the ratio of the Value added (current US$) in Least developed countries in 2001 to that in 2006?
Ensure brevity in your answer.  0.57. What is the ratio of the Value added (current US$) of Comoros in 2001 to that in 2006?
Your response must be concise. 0.54. What is the ratio of the Value added (current US$) in Jamaica in 2001 to that in 2006?
Give a very brief answer. 0.76. What is the ratio of the Value added (current US$) in West Bank and Gaza in 2001 to that in 2006?
Your response must be concise. 0.77. What is the ratio of the Value added (current US$) of Least developed countries in 2002 to that in 2003?
Offer a terse response. 0.88. What is the ratio of the Value added (current US$) of Comoros in 2002 to that in 2003?
Provide a short and direct response. 0.78. What is the ratio of the Value added (current US$) of Jamaica in 2002 to that in 2003?
Offer a very short reply. 1.04. What is the ratio of the Value added (current US$) in West Bank and Gaza in 2002 to that in 2003?
Make the answer very short. 0.95. What is the ratio of the Value added (current US$) of Least developed countries in 2002 to that in 2004?
Provide a succinct answer. 0.78. What is the ratio of the Value added (current US$) of Comoros in 2002 to that in 2004?
Your answer should be very brief. 0.67. What is the ratio of the Value added (current US$) of Jamaica in 2002 to that in 2004?
Keep it short and to the point. 0.98. What is the ratio of the Value added (current US$) in West Bank and Gaza in 2002 to that in 2004?
Keep it short and to the point. 0.89. What is the ratio of the Value added (current US$) in Least developed countries in 2002 to that in 2005?
Your answer should be very brief. 0.68. What is the ratio of the Value added (current US$) of Comoros in 2002 to that in 2005?
Make the answer very short. 0.65. What is the ratio of the Value added (current US$) of Jamaica in 2002 to that in 2005?
Provide a short and direct response. 0.89. What is the ratio of the Value added (current US$) of West Bank and Gaza in 2002 to that in 2005?
Keep it short and to the point. 0.8. What is the ratio of the Value added (current US$) in Least developed countries in 2002 to that in 2006?
Your answer should be very brief. 0.6. What is the ratio of the Value added (current US$) of Comoros in 2002 to that in 2006?
Keep it short and to the point. 0.6. What is the ratio of the Value added (current US$) of Jamaica in 2002 to that in 2006?
Offer a terse response. 0.83. What is the ratio of the Value added (current US$) of West Bank and Gaza in 2002 to that in 2006?
Keep it short and to the point. 0.76. What is the ratio of the Value added (current US$) of Least developed countries in 2003 to that in 2004?
Provide a succinct answer. 0.88. What is the ratio of the Value added (current US$) in Comoros in 2003 to that in 2004?
Your answer should be compact. 0.86. What is the ratio of the Value added (current US$) in Jamaica in 2003 to that in 2004?
Offer a terse response. 0.94. What is the ratio of the Value added (current US$) in West Bank and Gaza in 2003 to that in 2004?
Ensure brevity in your answer.  0.93. What is the ratio of the Value added (current US$) in Least developed countries in 2003 to that in 2005?
Provide a short and direct response. 0.77. What is the ratio of the Value added (current US$) of Comoros in 2003 to that in 2005?
Your response must be concise. 0.84. What is the ratio of the Value added (current US$) of Jamaica in 2003 to that in 2005?
Give a very brief answer. 0.85. What is the ratio of the Value added (current US$) in West Bank and Gaza in 2003 to that in 2005?
Provide a succinct answer. 0.85. What is the ratio of the Value added (current US$) in Least developed countries in 2003 to that in 2006?
Your answer should be very brief. 0.68. What is the ratio of the Value added (current US$) of Comoros in 2003 to that in 2006?
Ensure brevity in your answer.  0.78. What is the ratio of the Value added (current US$) of Jamaica in 2003 to that in 2006?
Provide a short and direct response. 0.79. What is the ratio of the Value added (current US$) in Least developed countries in 2004 to that in 2005?
Provide a succinct answer. 0.87. What is the ratio of the Value added (current US$) in Comoros in 2004 to that in 2005?
Ensure brevity in your answer.  0.97. What is the ratio of the Value added (current US$) in Jamaica in 2004 to that in 2005?
Provide a succinct answer. 0.9. What is the ratio of the Value added (current US$) of West Bank and Gaza in 2004 to that in 2005?
Keep it short and to the point. 0.91. What is the ratio of the Value added (current US$) of Least developed countries in 2004 to that in 2006?
Offer a very short reply. 0.77. What is the ratio of the Value added (current US$) in Comoros in 2004 to that in 2006?
Your response must be concise. 0.9. What is the ratio of the Value added (current US$) of Jamaica in 2004 to that in 2006?
Your answer should be very brief. 0.84. What is the ratio of the Value added (current US$) of West Bank and Gaza in 2004 to that in 2006?
Your response must be concise. 0.86. What is the ratio of the Value added (current US$) of Least developed countries in 2005 to that in 2006?
Make the answer very short. 0.89. What is the ratio of the Value added (current US$) in Comoros in 2005 to that in 2006?
Provide a short and direct response. 0.93. What is the ratio of the Value added (current US$) of Jamaica in 2005 to that in 2006?
Provide a short and direct response. 0.94. What is the ratio of the Value added (current US$) in West Bank and Gaza in 2005 to that in 2006?
Offer a terse response. 0.95. What is the difference between the highest and the second highest Value added (current US$) of Least developed countries?
Give a very brief answer. 1.72e+1. What is the difference between the highest and the second highest Value added (current US$) of Comoros?
Offer a very short reply. 1.38e+07. What is the difference between the highest and the second highest Value added (current US$) of Jamaica?
Provide a succinct answer. 4.69e+08. What is the difference between the highest and the second highest Value added (current US$) in West Bank and Gaza?
Your answer should be compact. 1.62e+08. What is the difference between the highest and the lowest Value added (current US$) in Least developed countries?
Provide a short and direct response. 6.68e+1. What is the difference between the highest and the lowest Value added (current US$) in Comoros?
Make the answer very short. 9.08e+07. What is the difference between the highest and the lowest Value added (current US$) in Jamaica?
Provide a succinct answer. 1.86e+09. What is the difference between the highest and the lowest Value added (current US$) of West Bank and Gaza?
Keep it short and to the point. 7.10e+08. 